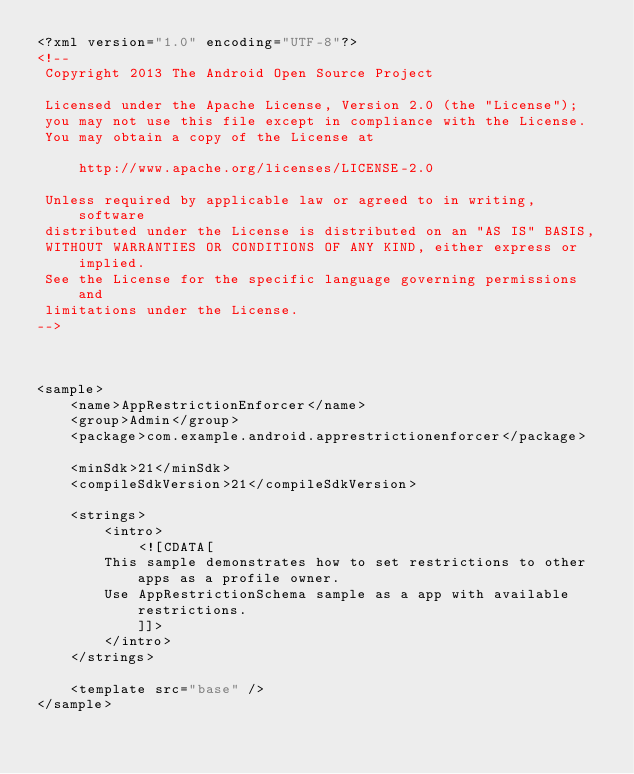Convert code to text. <code><loc_0><loc_0><loc_500><loc_500><_XML_><?xml version="1.0" encoding="UTF-8"?>
<!--
 Copyright 2013 The Android Open Source Project

 Licensed under the Apache License, Version 2.0 (the "License");
 you may not use this file except in compliance with the License.
 You may obtain a copy of the License at

     http://www.apache.org/licenses/LICENSE-2.0

 Unless required by applicable law or agreed to in writing, software
 distributed under the License is distributed on an "AS IS" BASIS,
 WITHOUT WARRANTIES OR CONDITIONS OF ANY KIND, either express or implied.
 See the License for the specific language governing permissions and
 limitations under the License.
-->



<sample>
    <name>AppRestrictionEnforcer</name>
    <group>Admin</group>
    <package>com.example.android.apprestrictionenforcer</package>

    <minSdk>21</minSdk>
    <compileSdkVersion>21</compileSdkVersion>

    <strings>
        <intro>
            <![CDATA[
	    This sample demonstrates how to set restrictions to other apps as a profile owner.
	    Use AppRestrictionSchema sample as a app with available restrictions.
            ]]>
        </intro>
    </strings>

    <template src="base" />
</sample>
</code> 